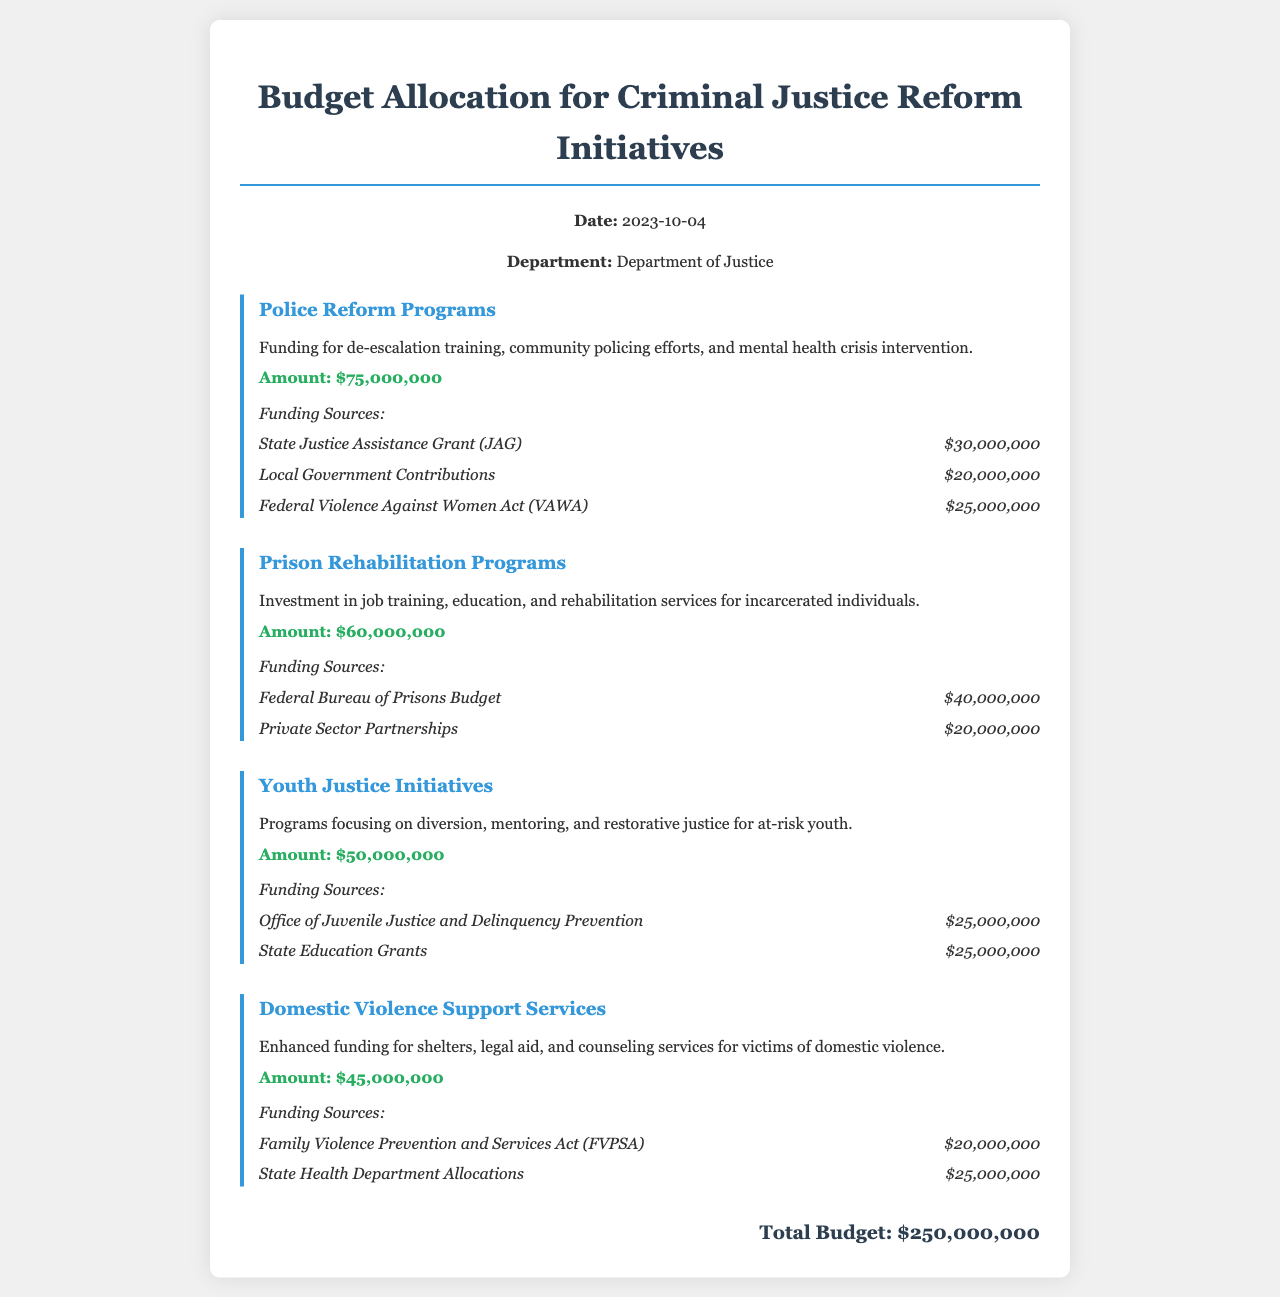What is the date of the budget allocation? The date of the budget allocation is specified in the header of the document as "2023-10-04".
Answer: 2023-10-04 What is the total budget for criminal justice reform initiatives? The total budget is provided at the bottom of the document and sums all initiatives, amounting to $250,000,000.
Answer: $250,000,000 How much funding is allocated for Police Reform Programs? The amount for Police Reform Programs is detailed under that initiative as $75,000,000.
Answer: $75,000,000 Which funding source contributes the most to Prison Rehabilitation Programs? The largest funding source for Prison Rehabilitation Programs comes from the Federal Bureau of Prisons Budget, listed as $40,000,000.
Answer: Federal Bureau of Prisons Budget What type of initiatives are included in Youth Justice Initiatives? The document describes Youth Justice Initiatives as focusing on diversion, mentoring, and restorative justice for at-risk youth, which are specific program types.
Answer: diversion, mentoring, and restorative justice How much is allocated to Domestic Violence Support Services? The allocated amount for Domestic Violence Support Services is mentioned clearly as $45,000,000.
Answer: $45,000,000 What is the funding source for Youth Justice Initiatives that is not from the Office of Juvenile Justice and Delinquency Prevention? The other funding source listed for Youth Justice Initiatives is State Education Grants, which contributes a total of $25,000,000.
Answer: State Education Grants Which initiative has the smallest budget allocation? By comparing all initiatives, the one with the smallest allocation is Domestic Violence Support Services at $45,000,000.
Answer: Domestic Violence Support Services What is the total amount allocated for Prison Rehabilitation Programs funding sources? The funding sources for Prison Rehabilitation Programs total to $60,000,000, which is the direct allocation for this initiative.
Answer: $60,000,000 